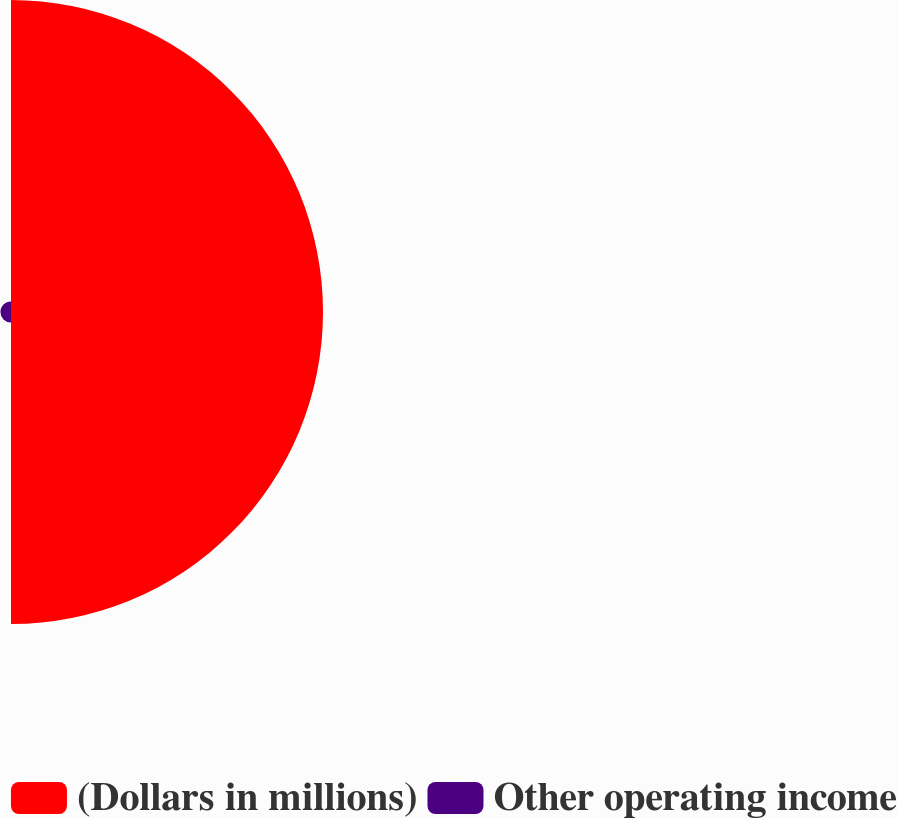Convert chart. <chart><loc_0><loc_0><loc_500><loc_500><pie_chart><fcel>(Dollars in millions)<fcel>Other operating income<nl><fcel>96.72%<fcel>3.28%<nl></chart> 